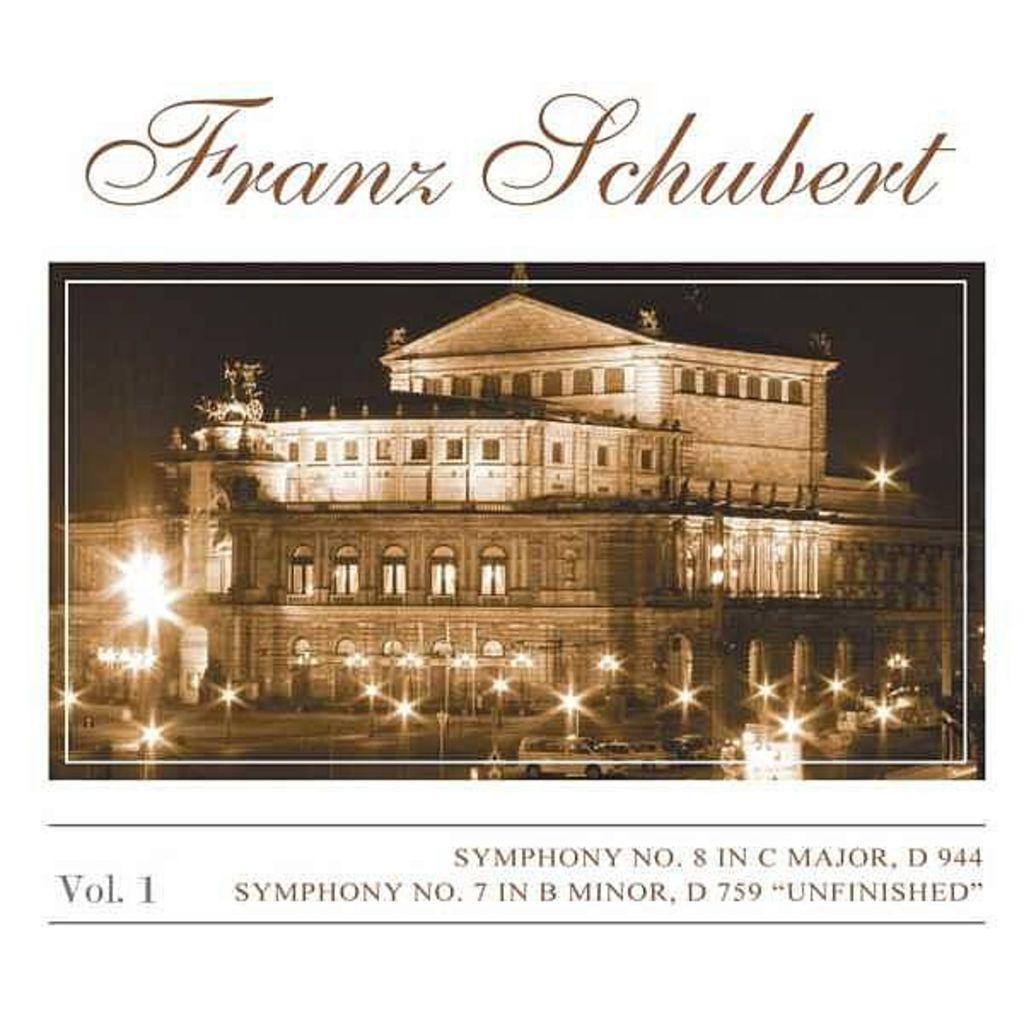Please provide a concise description of this image. In the picture I can see the building and glass windows. I can see the light poles in front of the building and I can see the cars parked on the side of the building. I can see the text at the top and at the bottom of the image. 